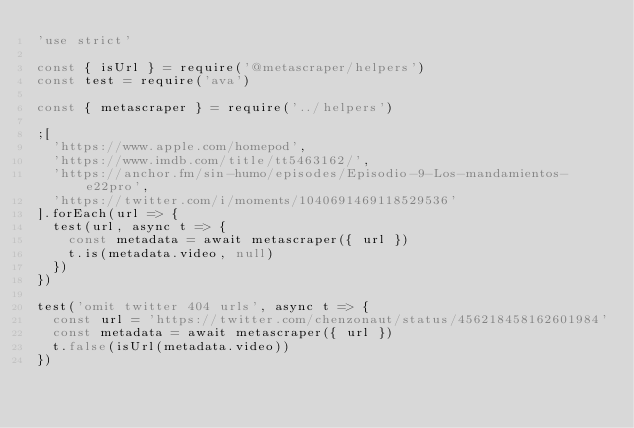Convert code to text. <code><loc_0><loc_0><loc_500><loc_500><_JavaScript_>'use strict'

const { isUrl } = require('@metascraper/helpers')
const test = require('ava')

const { metascraper } = require('../helpers')

;[
  'https://www.apple.com/homepod',
  'https://www.imdb.com/title/tt5463162/',
  'https://anchor.fm/sin-humo/episodes/Episodio-9-Los-mandamientos-e22pro',
  'https://twitter.com/i/moments/1040691469118529536'
].forEach(url => {
  test(url, async t => {
    const metadata = await metascraper({ url })
    t.is(metadata.video, null)
  })
})

test('omit twitter 404 urls', async t => {
  const url = 'https://twitter.com/chenzonaut/status/456218458162601984'
  const metadata = await metascraper({ url })
  t.false(isUrl(metadata.video))
})
</code> 